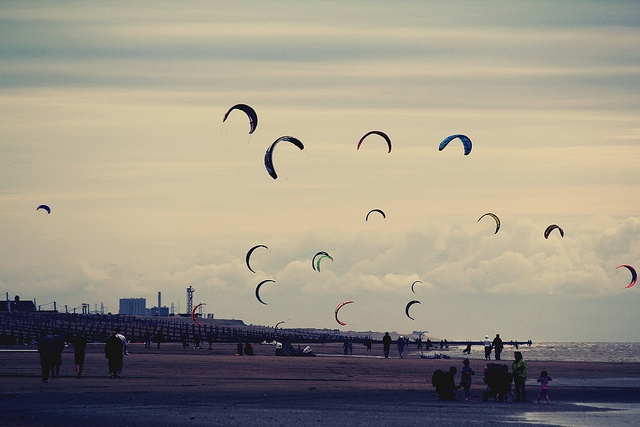Describe the objects in this image and their specific colors. I can see people in gray, black, and darkgray tones, people in black, navy, purple, and gray tones, people in gray, black, and navy tones, people in gray and black tones, and people in black and gray tones in this image. 